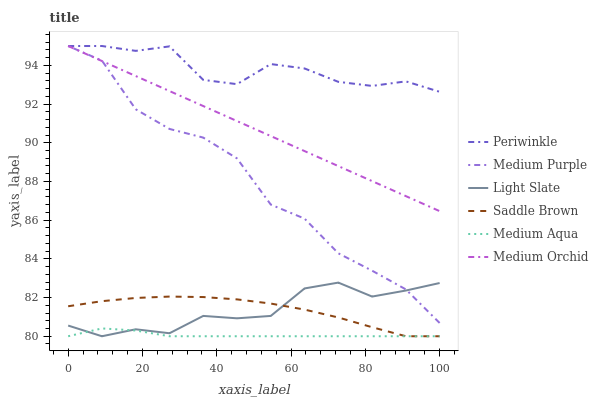Does Medium Aqua have the minimum area under the curve?
Answer yes or no. Yes. Does Periwinkle have the maximum area under the curve?
Answer yes or no. Yes. Does Medium Orchid have the minimum area under the curve?
Answer yes or no. No. Does Medium Orchid have the maximum area under the curve?
Answer yes or no. No. Is Medium Orchid the smoothest?
Answer yes or no. Yes. Is Medium Purple the roughest?
Answer yes or no. Yes. Is Medium Purple the smoothest?
Answer yes or no. No. Is Medium Orchid the roughest?
Answer yes or no. No. Does Light Slate have the lowest value?
Answer yes or no. Yes. Does Medium Orchid have the lowest value?
Answer yes or no. No. Does Periwinkle have the highest value?
Answer yes or no. Yes. Does Medium Aqua have the highest value?
Answer yes or no. No. Is Medium Aqua less than Medium Purple?
Answer yes or no. Yes. Is Medium Purple greater than Medium Aqua?
Answer yes or no. Yes. Does Medium Purple intersect Periwinkle?
Answer yes or no. Yes. Is Medium Purple less than Periwinkle?
Answer yes or no. No. Is Medium Purple greater than Periwinkle?
Answer yes or no. No. Does Medium Aqua intersect Medium Purple?
Answer yes or no. No. 